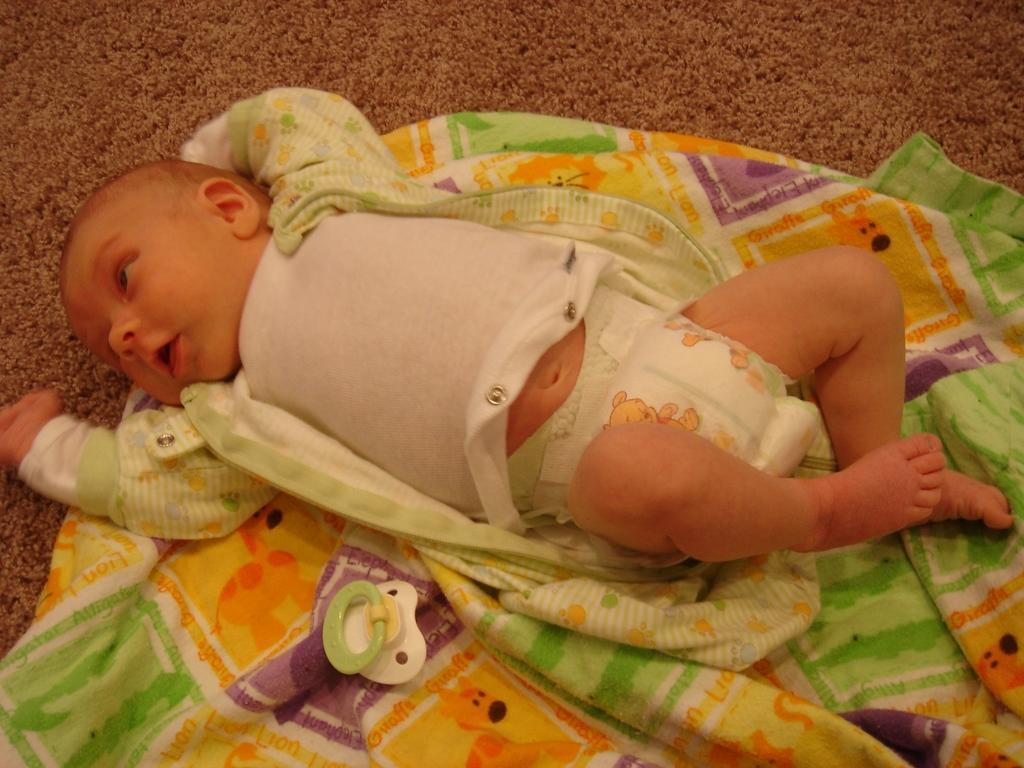In one or two sentences, can you explain what this image depicts? In this image in the center there is one baby who is sleeping on a blanket, and there is one toy. 